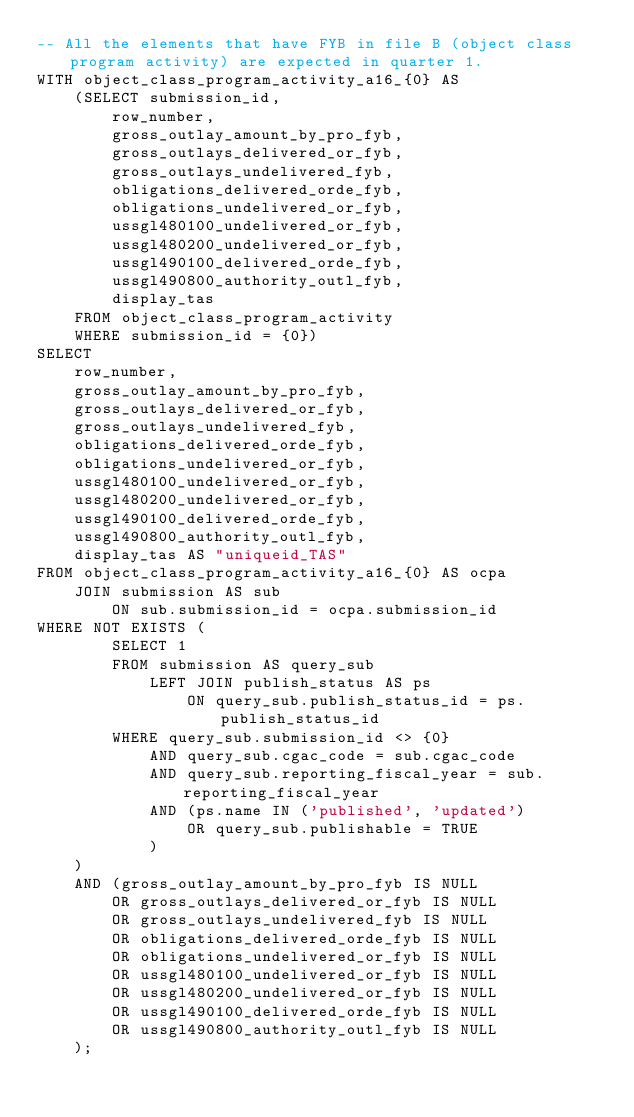<code> <loc_0><loc_0><loc_500><loc_500><_SQL_>-- All the elements that have FYB in file B (object class program activity) are expected in quarter 1.
WITH object_class_program_activity_a16_{0} AS
    (SELECT submission_id,
        row_number,
        gross_outlay_amount_by_pro_fyb,
        gross_outlays_delivered_or_fyb,
        gross_outlays_undelivered_fyb,
        obligations_delivered_orde_fyb,
        obligations_undelivered_or_fyb,
        ussgl480100_undelivered_or_fyb,
        ussgl480200_undelivered_or_fyb,
        ussgl490100_delivered_orde_fyb,
        ussgl490800_authority_outl_fyb,
        display_tas
    FROM object_class_program_activity
    WHERE submission_id = {0})
SELECT
    row_number,
    gross_outlay_amount_by_pro_fyb,
    gross_outlays_delivered_or_fyb,
    gross_outlays_undelivered_fyb,
    obligations_delivered_orde_fyb,
    obligations_undelivered_or_fyb,
    ussgl480100_undelivered_or_fyb,
    ussgl480200_undelivered_or_fyb,
    ussgl490100_delivered_orde_fyb,
    ussgl490800_authority_outl_fyb,
    display_tas AS "uniqueid_TAS"
FROM object_class_program_activity_a16_{0} AS ocpa
    JOIN submission AS sub
        ON sub.submission_id = ocpa.submission_id
WHERE NOT EXISTS (
        SELECT 1
        FROM submission AS query_sub
            LEFT JOIN publish_status AS ps
                ON query_sub.publish_status_id = ps.publish_status_id
        WHERE query_sub.submission_id <> {0}
            AND query_sub.cgac_code = sub.cgac_code
            AND query_sub.reporting_fiscal_year = sub.reporting_fiscal_year
            AND (ps.name IN ('published', 'updated')
                OR query_sub.publishable = TRUE
            )
    )
    AND (gross_outlay_amount_by_pro_fyb IS NULL
        OR gross_outlays_delivered_or_fyb IS NULL
        OR gross_outlays_undelivered_fyb IS NULL
        OR obligations_delivered_orde_fyb IS NULL
        OR obligations_undelivered_or_fyb IS NULL
        OR ussgl480100_undelivered_or_fyb IS NULL
        OR ussgl480200_undelivered_or_fyb IS NULL
        OR ussgl490100_delivered_orde_fyb IS NULL
        OR ussgl490800_authority_outl_fyb IS NULL
    );
</code> 